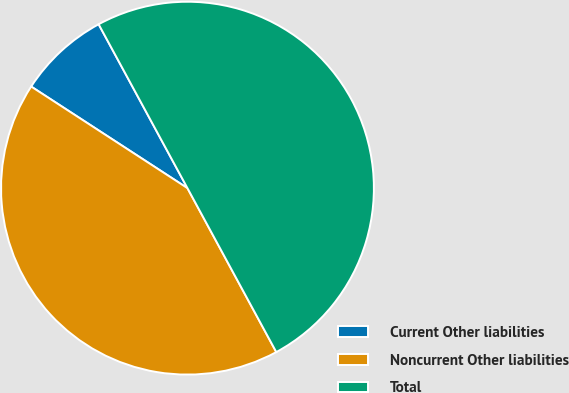Convert chart. <chart><loc_0><loc_0><loc_500><loc_500><pie_chart><fcel>Current Other liabilities<fcel>Noncurrent Other liabilities<fcel>Total<nl><fcel>7.92%<fcel>42.08%<fcel>50.0%<nl></chart> 